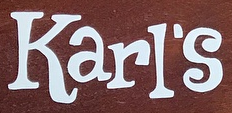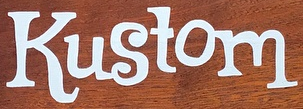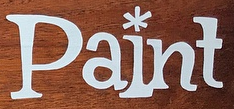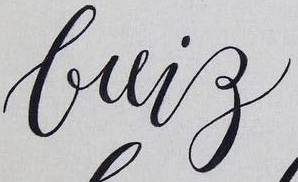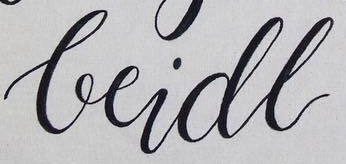Identify the words shown in these images in order, separated by a semicolon. Karl's; Kustom; Paint; brig; beidl 